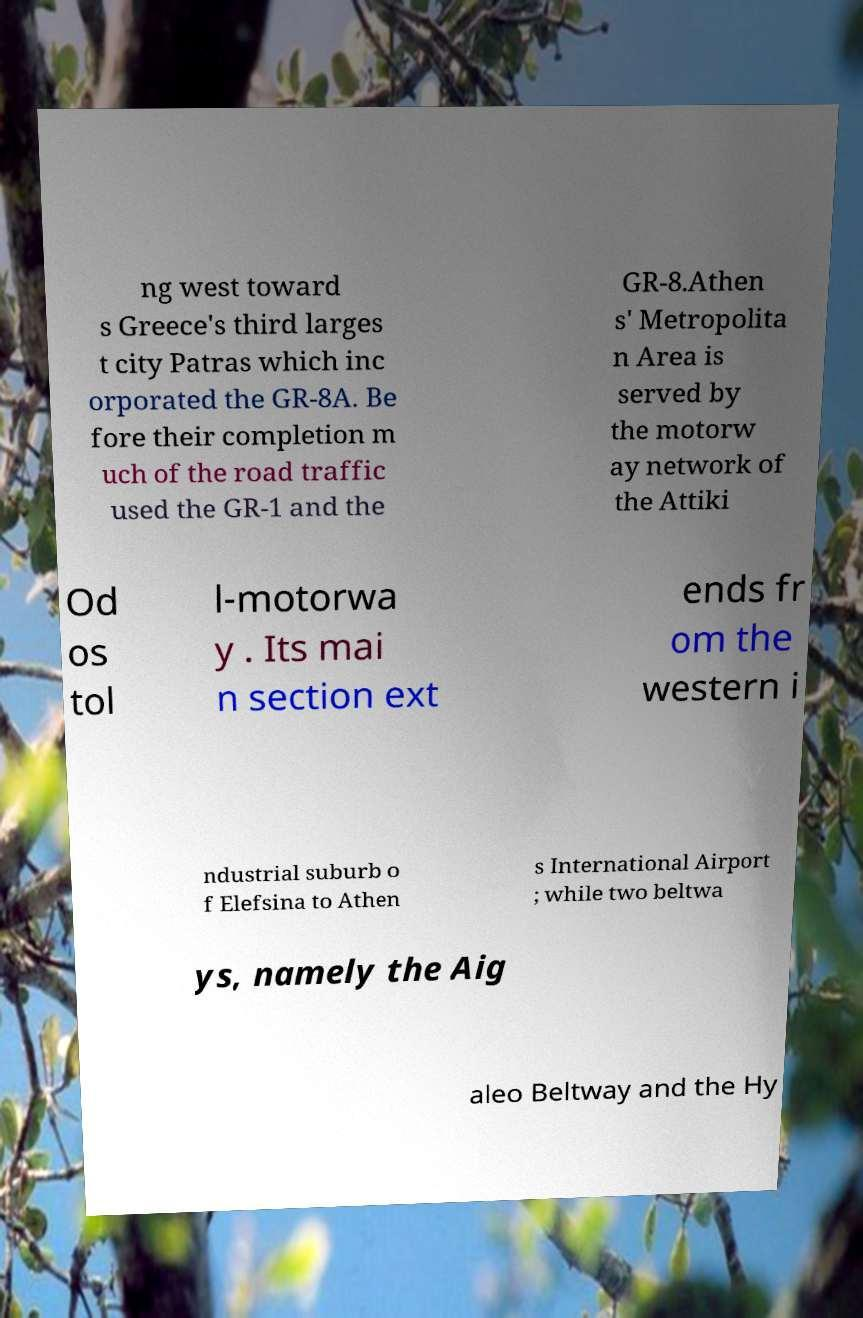Please identify and transcribe the text found in this image. ng west toward s Greece's third larges t city Patras which inc orporated the GR-8A. Be fore their completion m uch of the road traffic used the GR-1 and the GR-8.Athen s' Metropolita n Area is served by the motorw ay network of the Attiki Od os tol l-motorwa y . Its mai n section ext ends fr om the western i ndustrial suburb o f Elefsina to Athen s International Airport ; while two beltwa ys, namely the Aig aleo Beltway and the Hy 